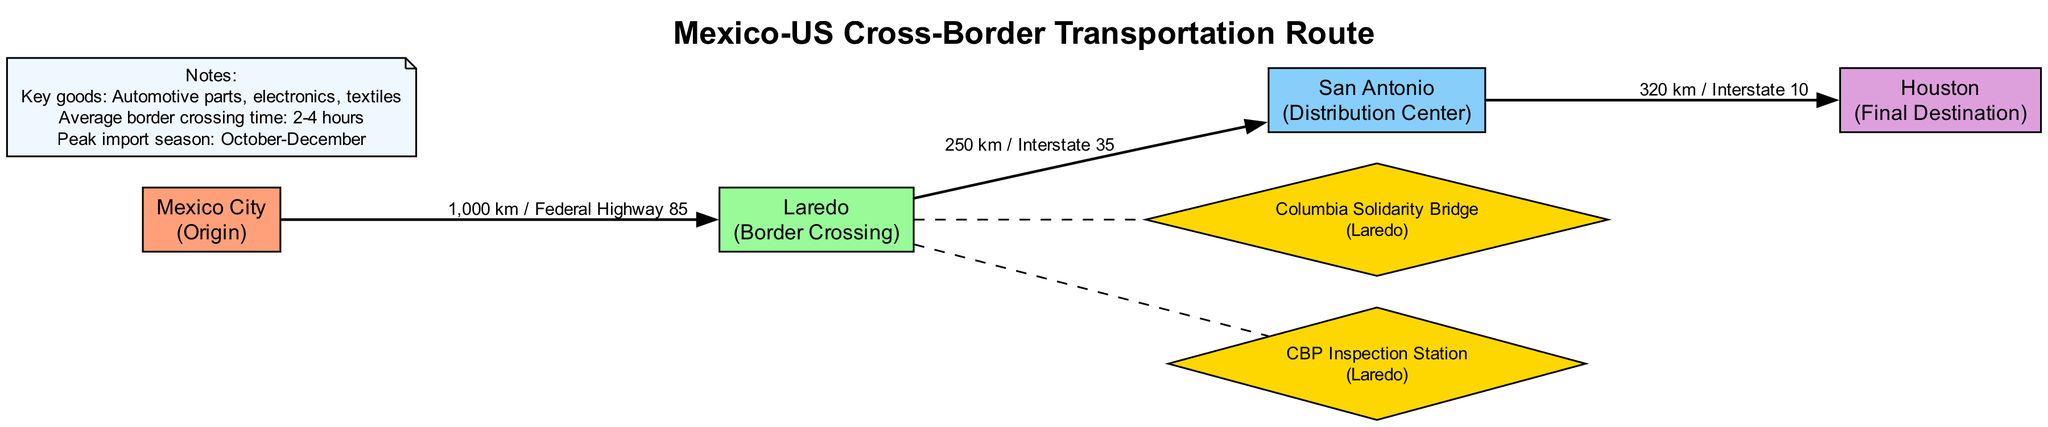What is the origin city in this transportation route? The origin city is clearly labeled in the diagram as "Mexico City" under the nodes list.
Answer: Mexico City How many edges are there in the diagram? The edges connecting the nodes are counted: there are three edges (from Mexico City to Laredo, Laredo to San Antonio, and San Antonio to Houston).
Answer: 3 What type of node is Laredo? By analyzing the nodes, it’s specified that Laredo is noted as a "Border Crossing."
Answer: Border Crossing What is the distance from Mexico City to Laredo? The edge connecting Mexico City to Laredo specifies the distance as "1,000 km."
Answer: 1,000 km What is the average border crossing time? The note section of the diagram states: "Average border crossing time: 2-4 hours."
Answer: 2-4 hours How far is the route from San Antonio to Houston? The edge from San Antonio to Houston states the distance is "320 km." Therefore, this direct information provides the answer.
Answer: 320 km How many checkpoints are there at the Laredo crossing? The diagram lists two checkpoints associated with Laredo: the Columbia Solidarity Bridge, and the CBP Inspection Station.
Answer: 2 What is the key good mentioned for importation? One of the key goods identified in the notes section includes "Automotive parts."
Answer: Automotive parts What major highway connects Laredo to San Antonio? The edge from Laredo to San Antonio specifies "Interstate 35" as the connecting route.
Answer: Interstate 35 